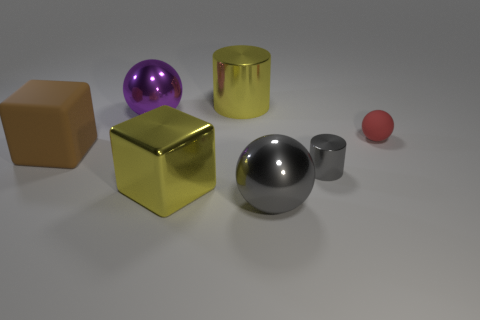How many metal things are left of the tiny gray shiny cylinder and in front of the small red matte ball?
Provide a succinct answer. 2. Do the yellow cylinder and the small sphere have the same material?
Provide a short and direct response. No. What shape is the big thing that is on the right side of the yellow shiny object behind the thing on the right side of the gray shiny cylinder?
Make the answer very short. Sphere. There is a large object that is both behind the tiny cylinder and in front of the tiny red object; what material is it?
Your response must be concise. Rubber. The matte thing that is to the right of the large sphere to the right of the big yellow object left of the large yellow cylinder is what color?
Your response must be concise. Red. How many cyan things are either large metallic objects or large cylinders?
Ensure brevity in your answer.  0. How many other things are the same size as the gray shiny cylinder?
Your answer should be compact. 1. How many big gray cubes are there?
Provide a short and direct response. 0. Are the block that is in front of the tiny gray shiny thing and the red sphere that is behind the large matte thing made of the same material?
Provide a short and direct response. No. What material is the large brown cube?
Offer a terse response. Rubber. 